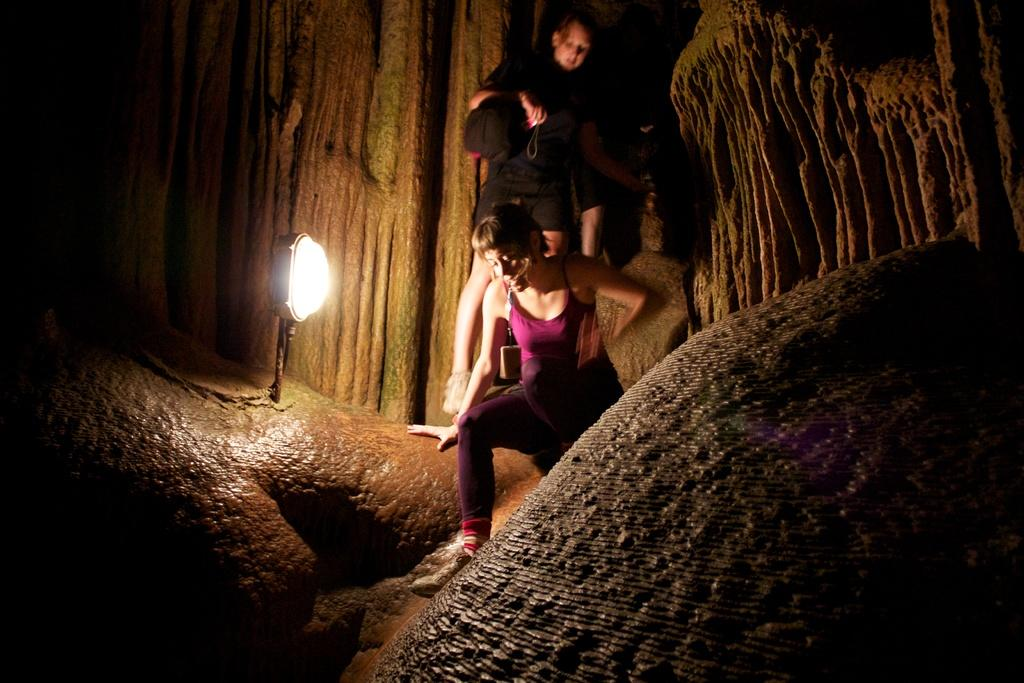How many people are in the image? There are two persons in the image. What can be seen on the left side of the image? There is a lamp on the left side of the image. What is located on the right side of the image? There is a rock on the right side of the image. Are there any cows wearing masks in the image? No, there are no cows or masks present in the image. 